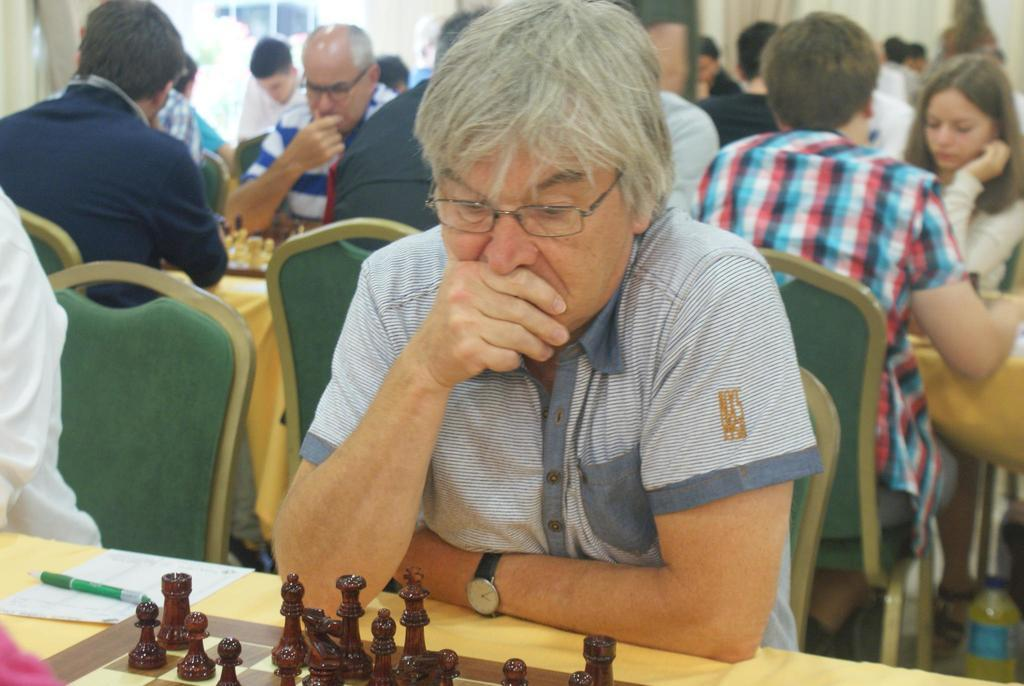What activity are the people in the image engaged in? The chess players in the image are playing a game of chess. What are the chess players sitting on while playing the game? The chess players are sitting on chairs. What is the main object on the table in the image? There is a chess board on the table. What type of pieces can be seen on the chess board? There are pawns on the chess board. Can you tell me how many goldfish are swimming in the chess board? There are no goldfish present in the image; it features a game of chess being played by two individuals. What type of motion is the chair exhibiting in the image? The chairs in the image are stationary, as the chess players are sitting on them while playing the game. 